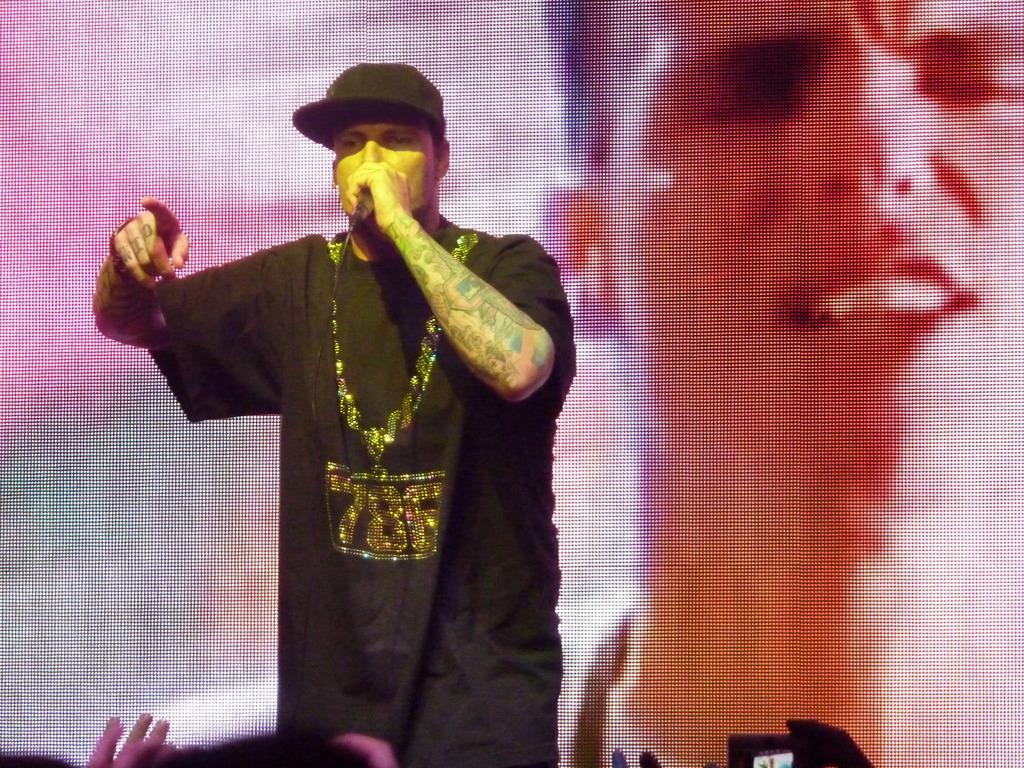Can you describe this image briefly? there is a person wearing black t shirt singing. he is wearing a black hat. 